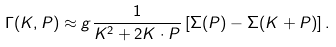Convert formula to latex. <formula><loc_0><loc_0><loc_500><loc_500>\Gamma ( K , P ) \approx g \frac { 1 } { K ^ { 2 } + 2 K \cdot P } \left [ \Sigma ( P ) - \Sigma ( K + P ) \right ] .</formula> 